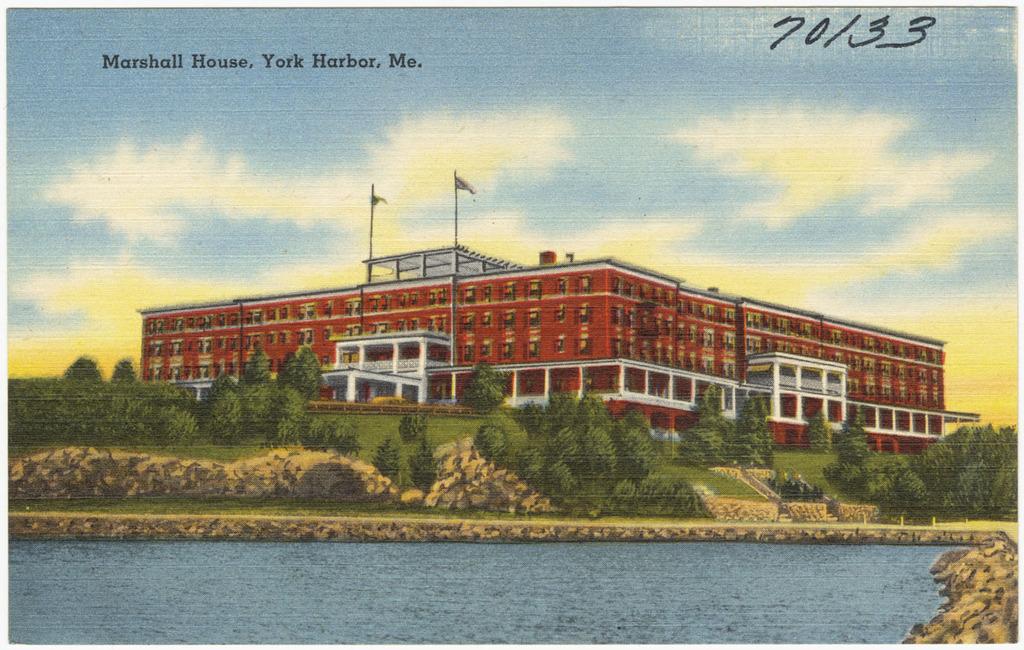Is this the marshall house?
Your response must be concise. Yes. 